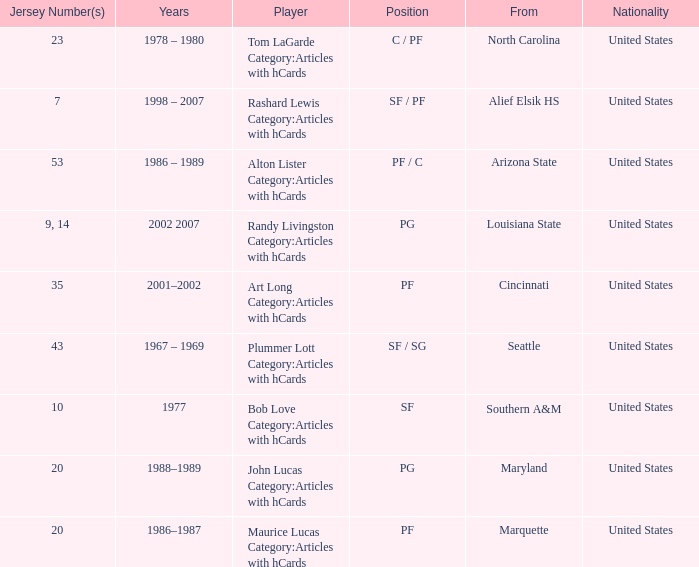Alton Lister Category:Articles with hCards has what as the listed years? 1986 – 1989. 